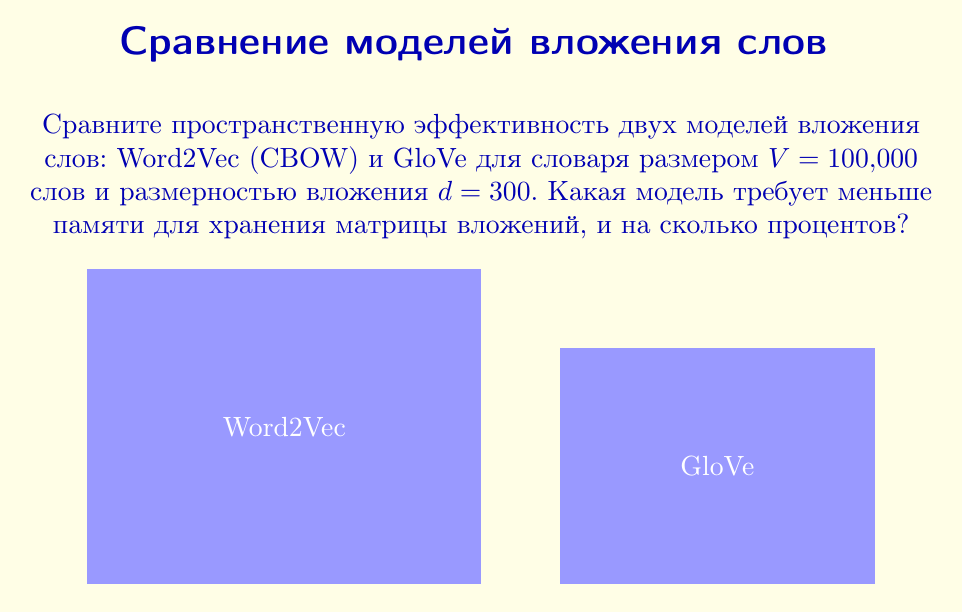Solve this math problem. 1) Для Word2Vec (CBOW):
   - Размер матрицы вложений: $V \times d = 100,000 \times 300$
   - Память: $M_{W2V} = 100,000 \times 300 \times 4$ байт (предполагая float32)
   - $M_{W2V} = 120,000,000$ байт $\approx 114.44$ МБ

2) Для GloVe:
   - Размер матрицы вложений: $V \times d = 100,000 \times 300$
   - Дополнительные векторы смещения: $V \times 1 = 100,000$
   - Общая память: $M_{GloVe} = (100,000 \times 300 + 100,000) \times 4$ байт
   - $M_{GloVe} = 120,400,000$ байт $\approx 114.82$ МБ

3) Разница в памяти:
   $\Delta M = M_{GloVe} - M_{W2V} = 400,000$ байт $\approx 0.38$ МБ

4) Процентная разница:
   $$\text{Процент} = \frac{\Delta M}{M_{W2V}} \times 100\% = \frac{400,000}{120,000,000} \times 100\% \approx 0.33\%$$
Answer: Word2Vec на 0.33% эффективнее GloVe 